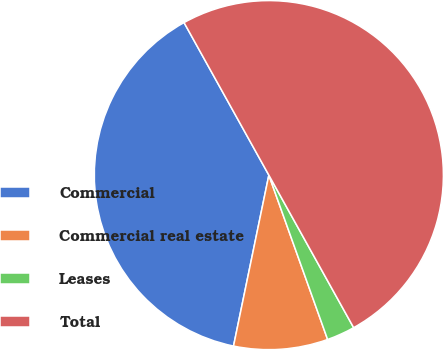Convert chart. <chart><loc_0><loc_0><loc_500><loc_500><pie_chart><fcel>Commercial<fcel>Commercial real estate<fcel>Leases<fcel>Total<nl><fcel>38.68%<fcel>8.71%<fcel>2.61%<fcel>50.0%<nl></chart> 